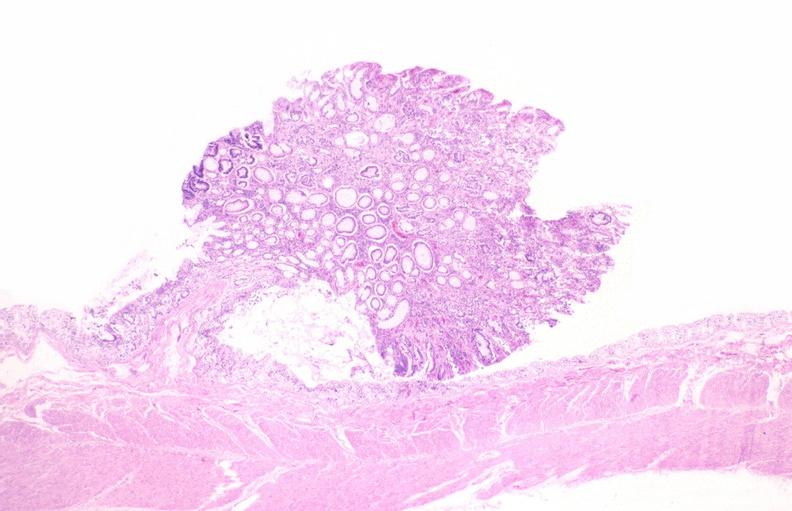what does this image show?
Answer the question using a single word or phrase. Colon 